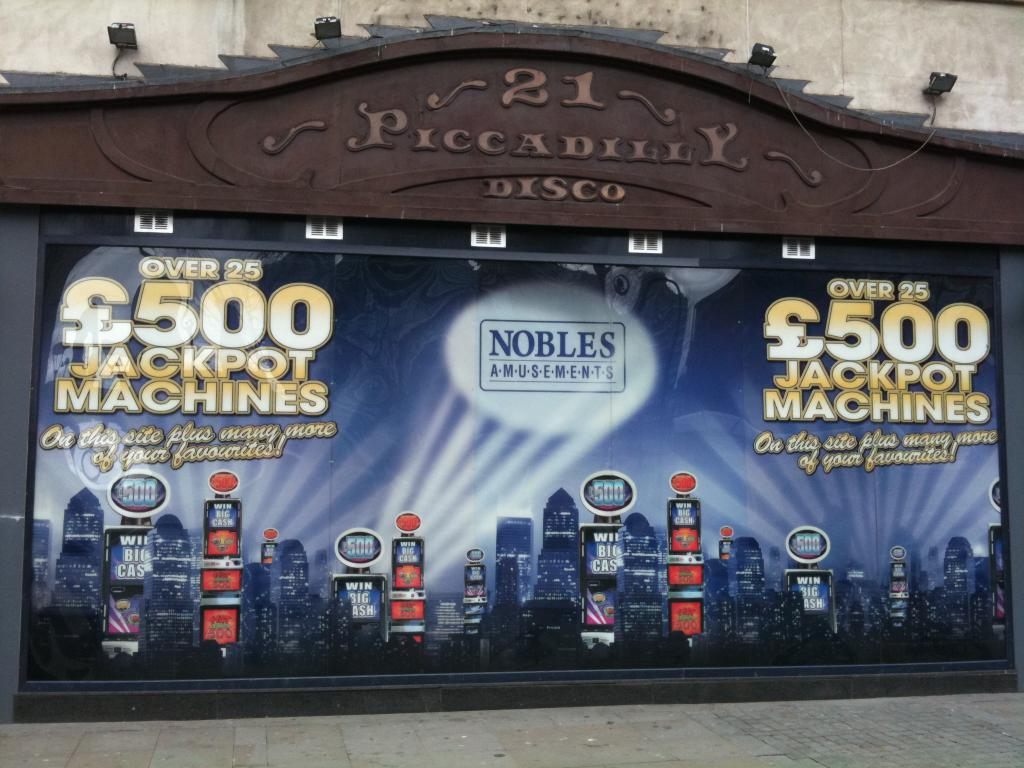What is the main subject in the center of the image? There is a poster in the center of the image. What structure can be seen at the top side of the image? There is an entrance arch at the top side of the image. What type of lighting is visible in the background? It appears that there are lamps in the background. What type of architectural feature is present in the background? There is a wall in the background of the image. How many people are massing together in the image? There is no indication of people massing together in the image; it primarily features a poster, an entrance arch, lamps, and a wall. What type of roll can be seen in the image? There is no roll present in the image. 